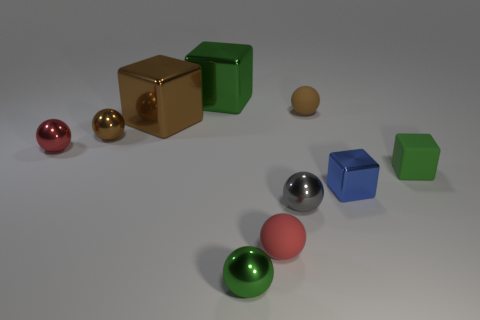Subtract all red balls. How many balls are left? 4 Subtract all red metal balls. How many balls are left? 5 Subtract 1 cubes. How many cubes are left? 3 Subtract all blue balls. Subtract all purple blocks. How many balls are left? 6 Subtract all cubes. How many objects are left? 6 Add 8 big green objects. How many big green objects exist? 9 Subtract 0 yellow balls. How many objects are left? 10 Subtract all tiny blue rubber cubes. Subtract all big brown blocks. How many objects are left? 9 Add 9 blue metallic cubes. How many blue metallic cubes are left? 10 